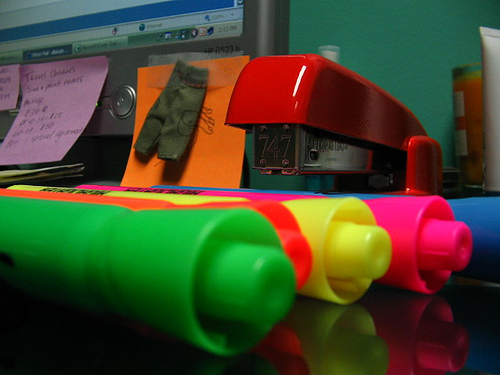<image>
Is there a monitor behind the marker? Yes. From this viewpoint, the monitor is positioned behind the marker, with the marker partially or fully occluding the monitor. Is there a stapler above the marker? Yes. The stapler is positioned above the marker in the vertical space, higher up in the scene. 